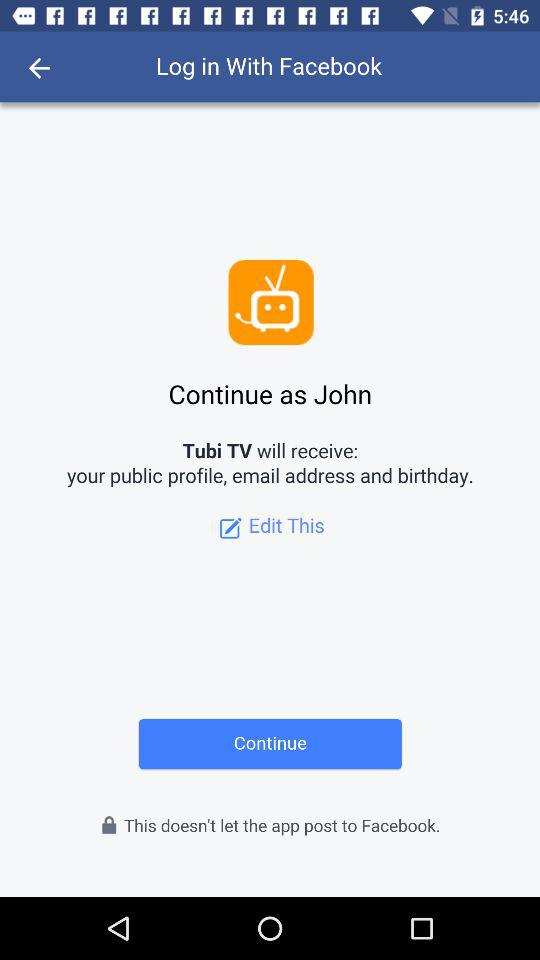What application will receive the public profile, email address and birthday? The application that will receive the public profile, email address and birthday is "Tubi TV". 